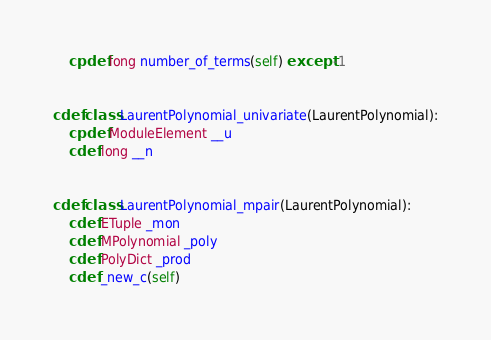Convert code to text. <code><loc_0><loc_0><loc_500><loc_500><_Cython_>    cpdef long number_of_terms(self) except -1


cdef class LaurentPolynomial_univariate(LaurentPolynomial):
    cpdef ModuleElement __u
    cdef long __n


cdef class LaurentPolynomial_mpair(LaurentPolynomial):
    cdef ETuple _mon
    cdef MPolynomial _poly
    cdef PolyDict _prod
    cdef _new_c(self)
</code> 